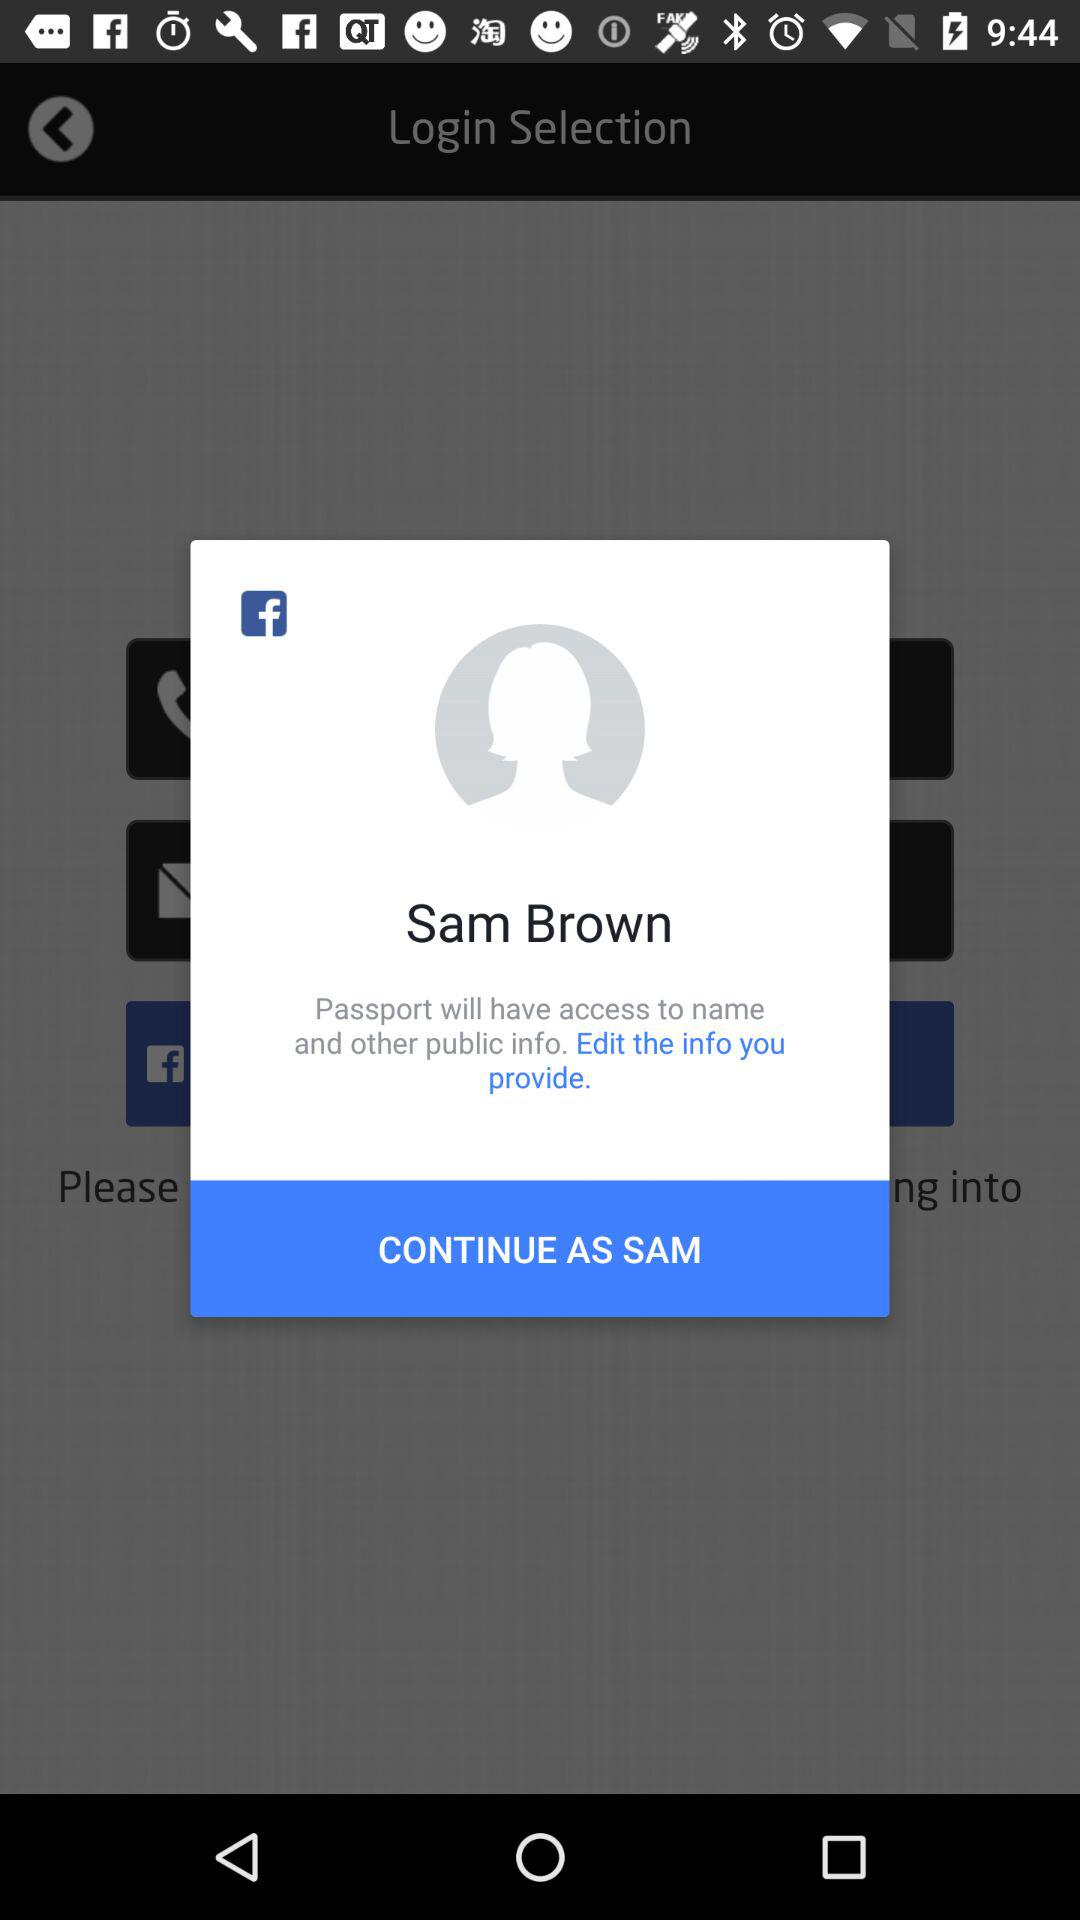Through what application should I log in? You should log in through "Facebook". 